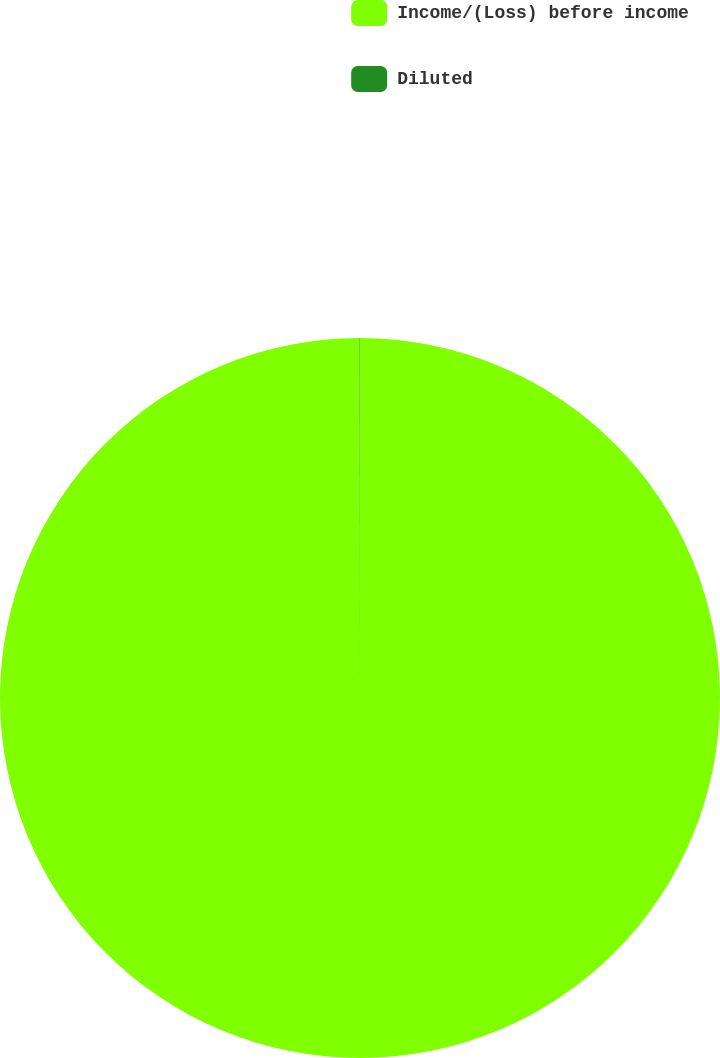<chart> <loc_0><loc_0><loc_500><loc_500><pie_chart><fcel>Income/(Loss) before income<fcel>Diluted<nl><fcel>99.98%<fcel>0.02%<nl></chart> 